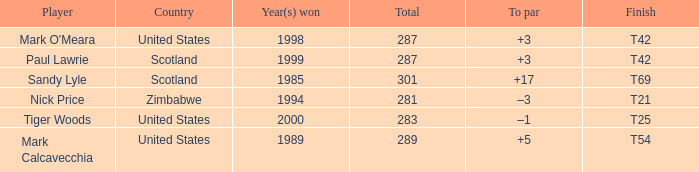What is the to par when the year(s) won is larger than 1999? –1. 